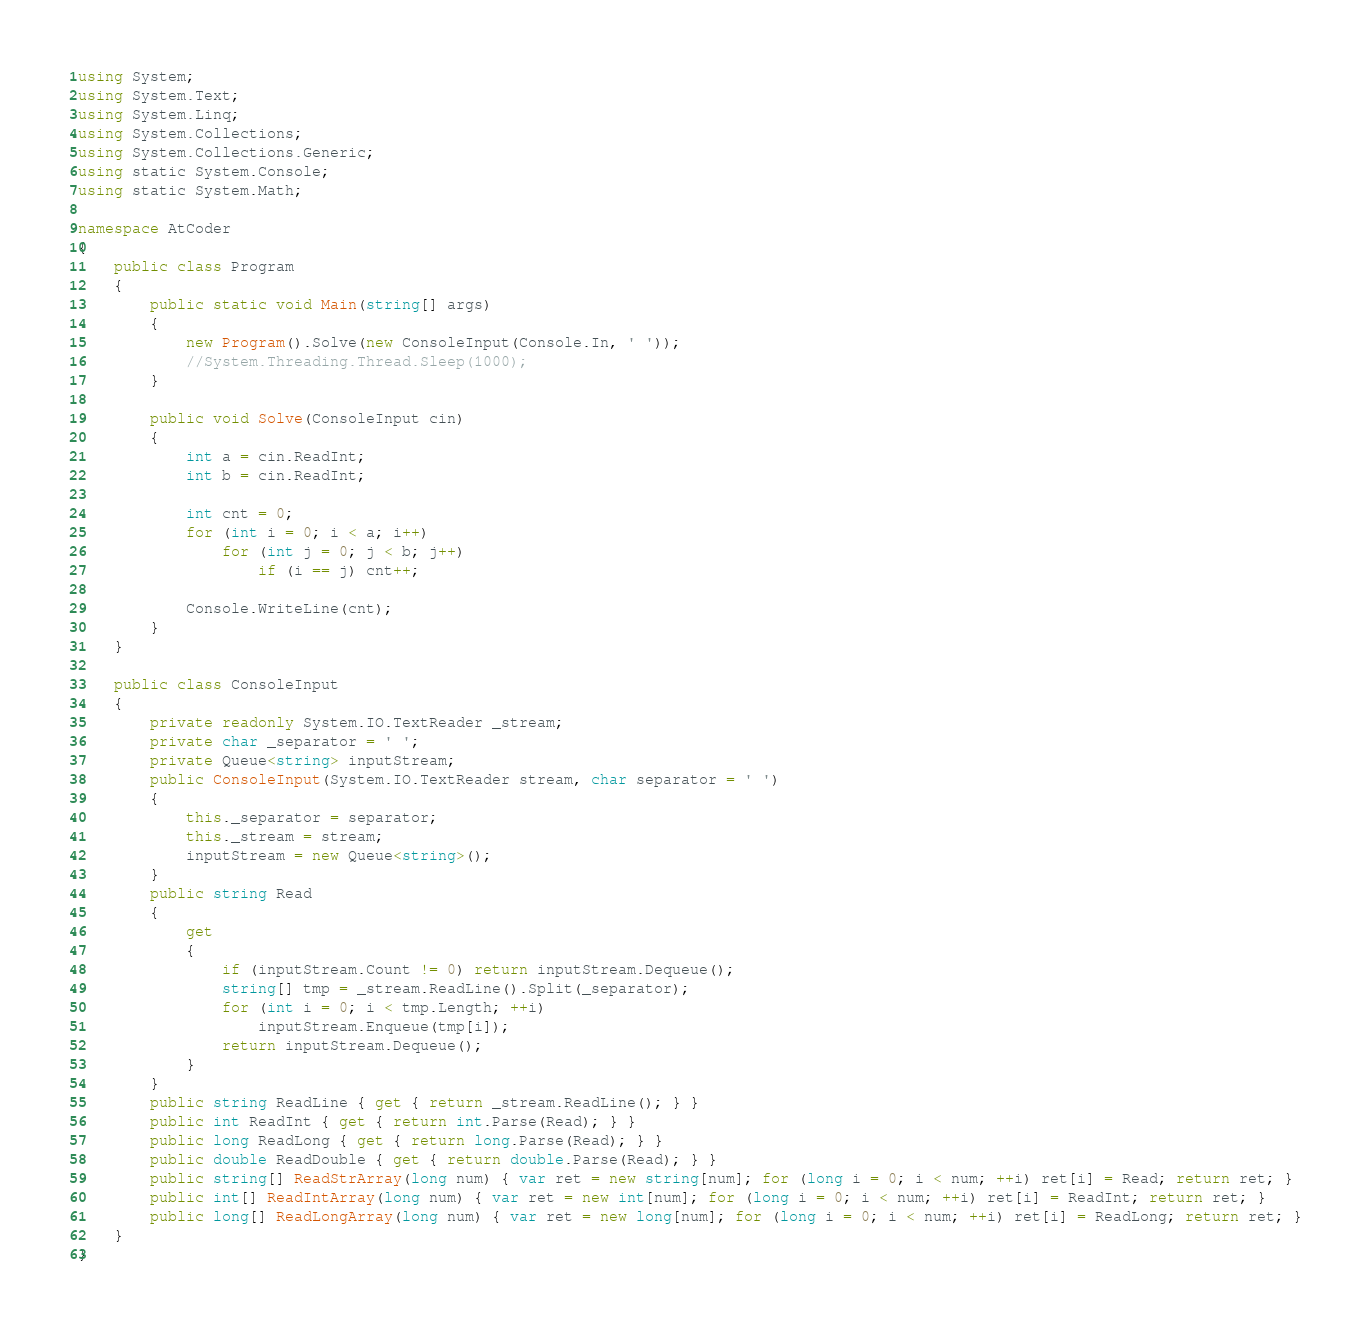<code> <loc_0><loc_0><loc_500><loc_500><_C#_>using System;
using System.Text;
using System.Linq;
using System.Collections;
using System.Collections.Generic;
using static System.Console;
using static System.Math;

namespace AtCoder
{
    public class Program
    {
        public static void Main(string[] args)
        {
            new Program().Solve(new ConsoleInput(Console.In, ' '));
            //System.Threading.Thread.Sleep(1000);
        }

        public void Solve(ConsoleInput cin)
        {
            int a = cin.ReadInt;
            int b = cin.ReadInt;

            int cnt = 0;
            for (int i = 0; i < a; i++)
                for (int j = 0; j < b; j++)
                    if (i == j) cnt++;

            Console.WriteLine(cnt);
        }
    }

    public class ConsoleInput
    {
        private readonly System.IO.TextReader _stream;
        private char _separator = ' ';
        private Queue<string> inputStream;
        public ConsoleInput(System.IO.TextReader stream, char separator = ' ')
        {
            this._separator = separator;
            this._stream = stream;
            inputStream = new Queue<string>();
        }
        public string Read
        {
            get
            {
                if (inputStream.Count != 0) return inputStream.Dequeue();
                string[] tmp = _stream.ReadLine().Split(_separator);
                for (int i = 0; i < tmp.Length; ++i)
                    inputStream.Enqueue(tmp[i]);
                return inputStream.Dequeue();
            }
        }
        public string ReadLine { get { return _stream.ReadLine(); } }
        public int ReadInt { get { return int.Parse(Read); } }
        public long ReadLong { get { return long.Parse(Read); } }
        public double ReadDouble { get { return double.Parse(Read); } }
        public string[] ReadStrArray(long num) { var ret = new string[num]; for (long i = 0; i < num; ++i) ret[i] = Read; return ret; }
        public int[] ReadIntArray(long num) { var ret = new int[num]; for (long i = 0; i < num; ++i) ret[i] = ReadInt; return ret; }
        public long[] ReadLongArray(long num) { var ret = new long[num]; for (long i = 0; i < num; ++i) ret[i] = ReadLong; return ret; }
    }
}</code> 